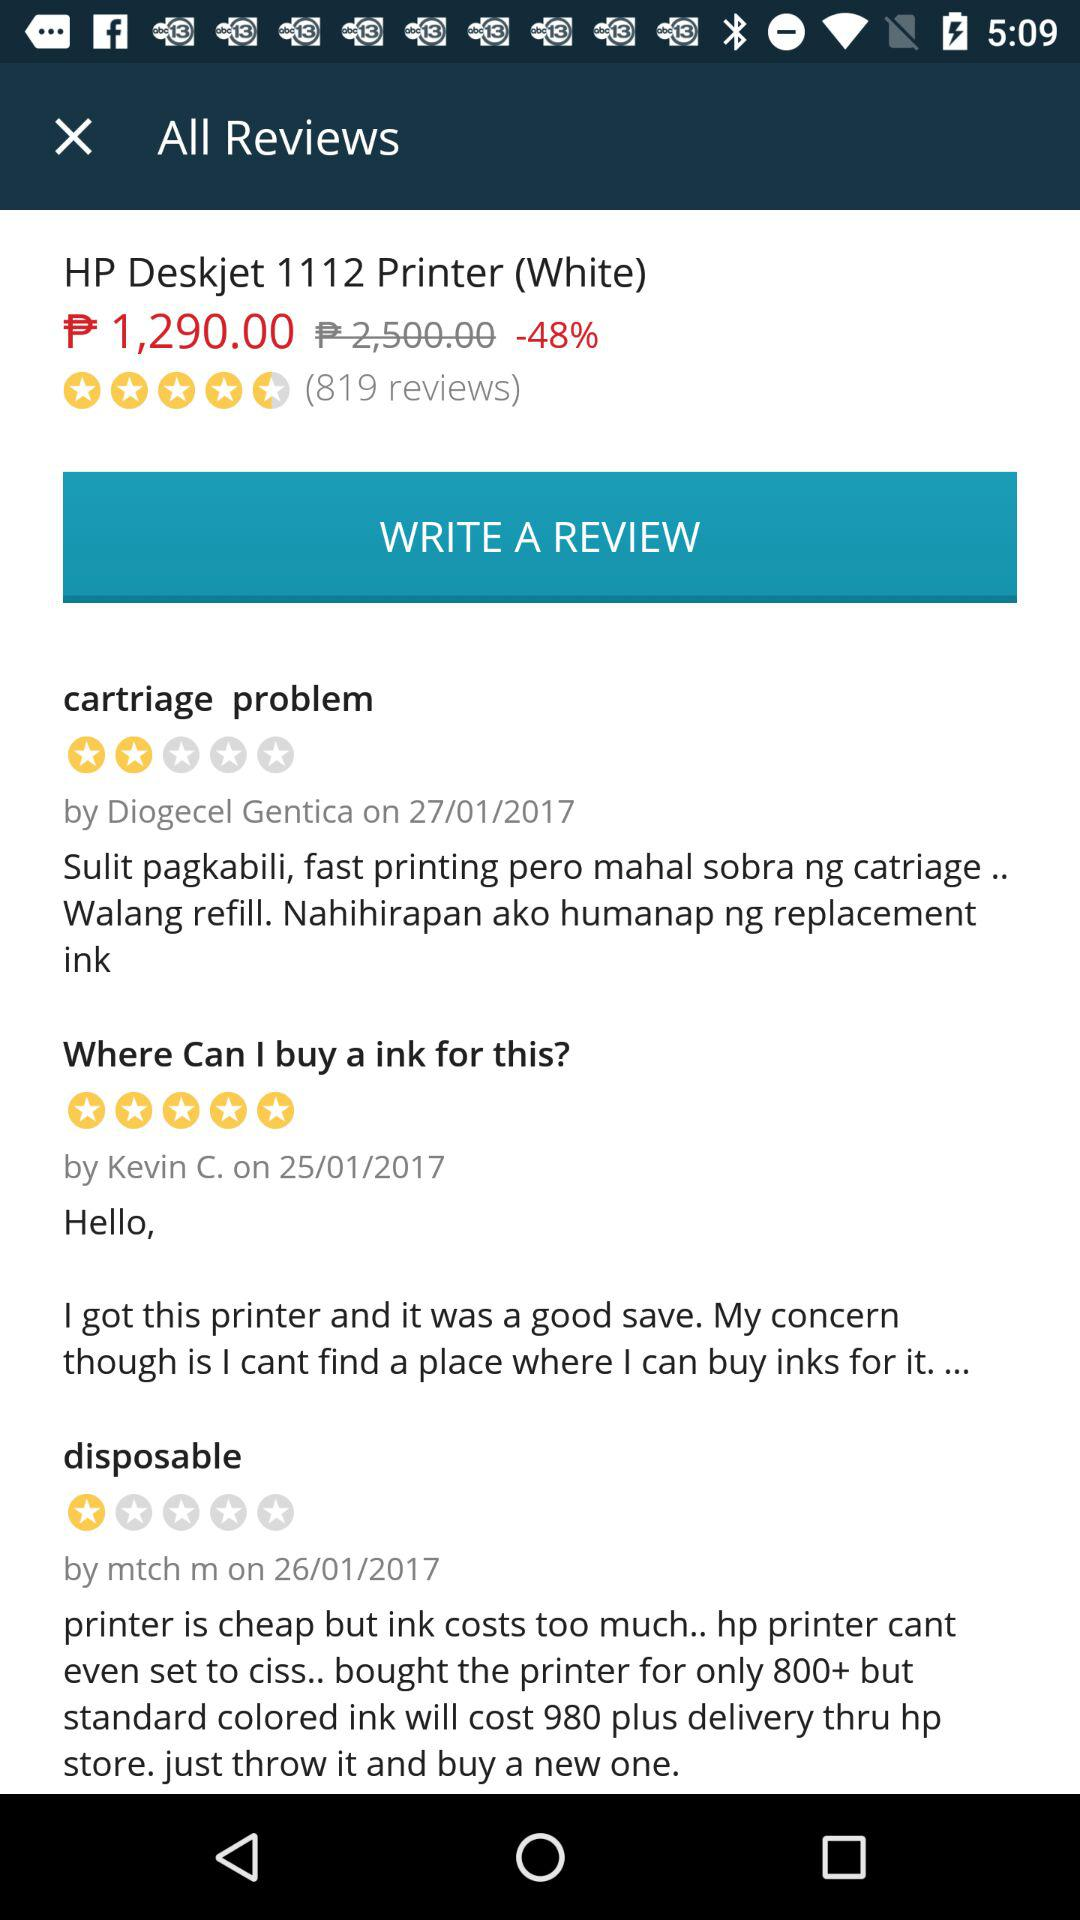Who gave the review on cartriage problems? The review was given by Diogecel Gentica. 